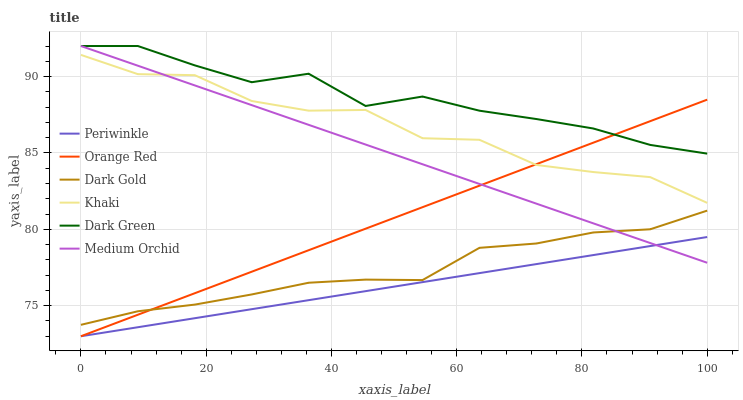Does Periwinkle have the minimum area under the curve?
Answer yes or no. Yes. Does Dark Green have the maximum area under the curve?
Answer yes or no. Yes. Does Dark Gold have the minimum area under the curve?
Answer yes or no. No. Does Dark Gold have the maximum area under the curve?
Answer yes or no. No. Is Medium Orchid the smoothest?
Answer yes or no. Yes. Is Khaki the roughest?
Answer yes or no. Yes. Is Dark Gold the smoothest?
Answer yes or no. No. Is Dark Gold the roughest?
Answer yes or no. No. Does Periwinkle have the lowest value?
Answer yes or no. Yes. Does Dark Gold have the lowest value?
Answer yes or no. No. Does Dark Green have the highest value?
Answer yes or no. Yes. Does Dark Gold have the highest value?
Answer yes or no. No. Is Periwinkle less than Dark Green?
Answer yes or no. Yes. Is Dark Green greater than Dark Gold?
Answer yes or no. Yes. Does Periwinkle intersect Medium Orchid?
Answer yes or no. Yes. Is Periwinkle less than Medium Orchid?
Answer yes or no. No. Is Periwinkle greater than Medium Orchid?
Answer yes or no. No. Does Periwinkle intersect Dark Green?
Answer yes or no. No. 